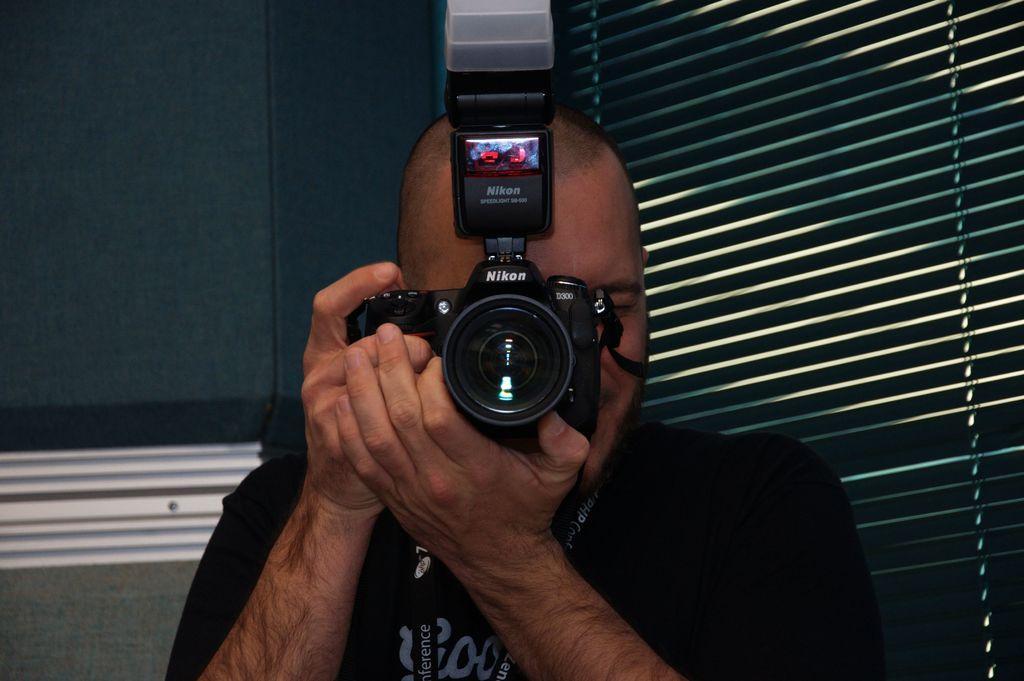In one or two sentences, can you explain what this image depicts? In this image we can see the person standing and holding a camera. And at the back we can see the wall and window shades. 